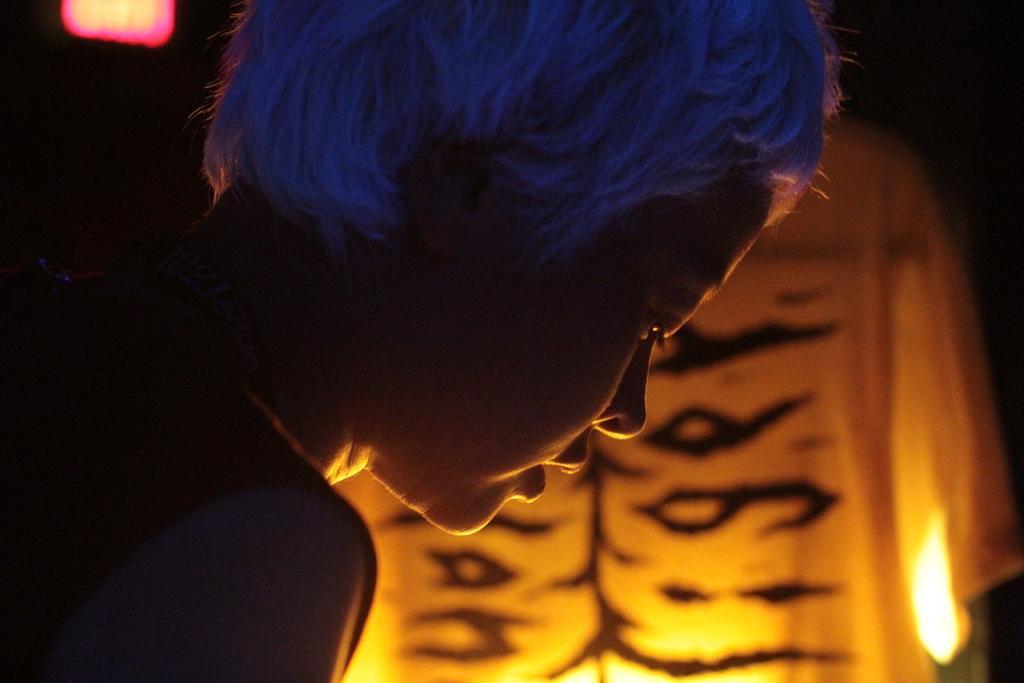Can you describe this image briefly? On the left side of the image we can see a lady is bending. In the background of the image we can see the lights and cloth. 